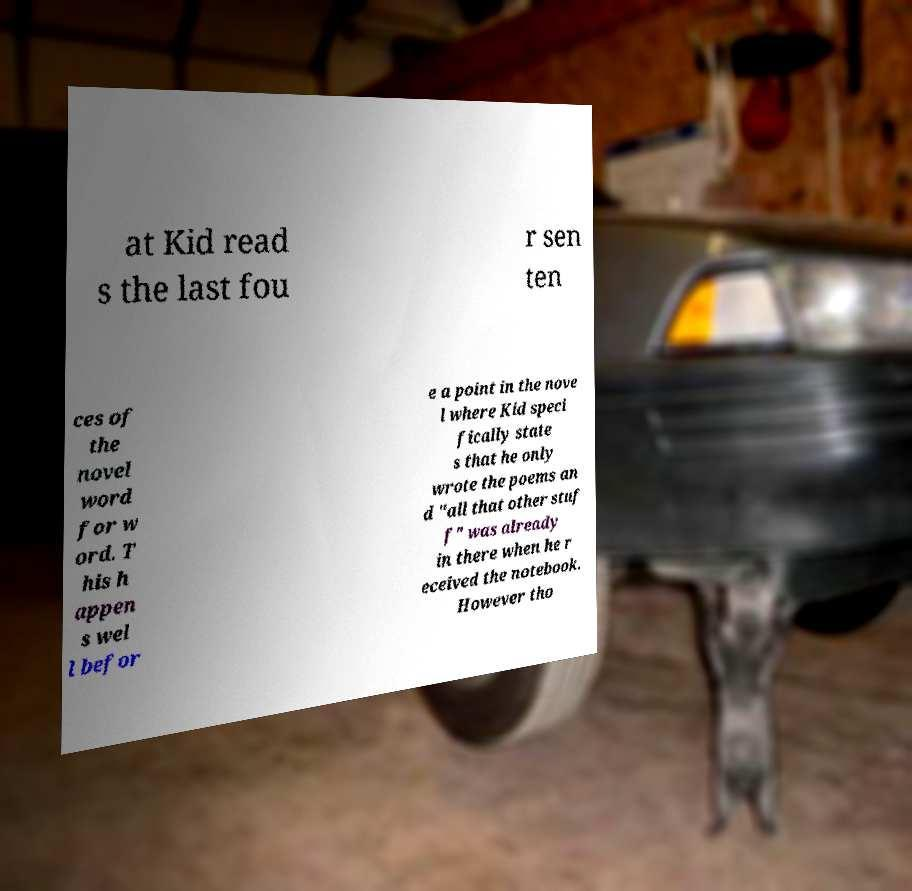For documentation purposes, I need the text within this image transcribed. Could you provide that? at Kid read s the last fou r sen ten ces of the novel word for w ord. T his h appen s wel l befor e a point in the nove l where Kid speci fically state s that he only wrote the poems an d "all that other stuf f" was already in there when he r eceived the notebook. However tho 